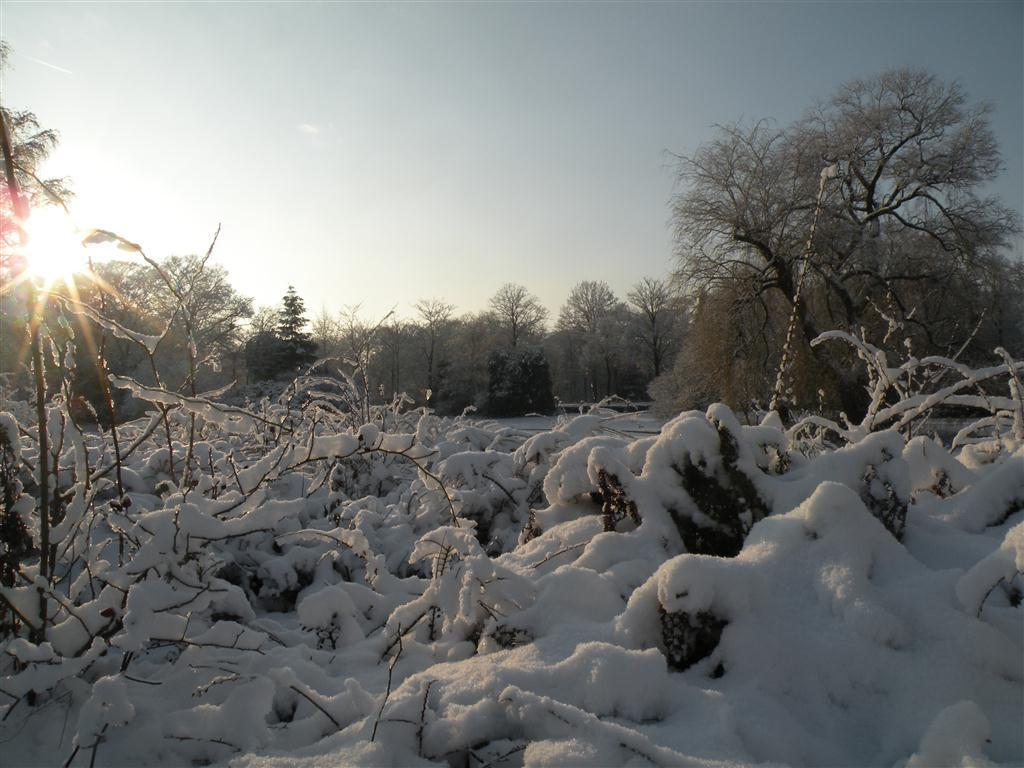What type of weather condition is depicted at the bottom of the image? There is snow at the bottom of the image. What type of natural environment can be seen in the background of the image? There are trees in the background of the image. What is visible at the top of the image? The sky is visible at the top of the image. What type of cake is being served in the image? There is no cake present in the image. How does the cork affect the snow in the image? There is no cork present in the image, so it cannot affect the snow. 